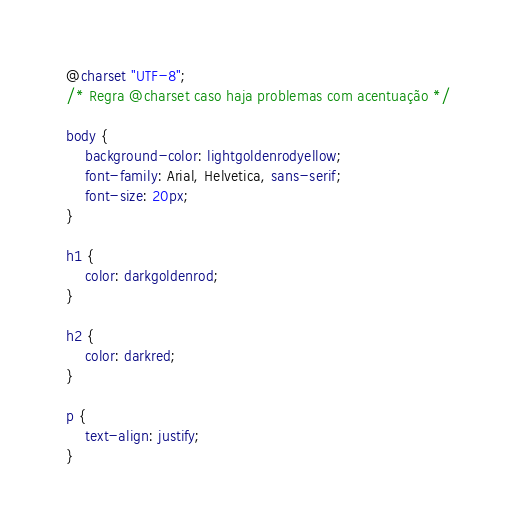<code> <loc_0><loc_0><loc_500><loc_500><_CSS_>@charset "UTF-8";
/* Regra @charset caso haja problemas com acentuação */

body {
    background-color: lightgoldenrodyellow;
    font-family: Arial, Helvetica, sans-serif;
    font-size: 20px;
}

h1 {
    color: darkgoldenrod;
}

h2 {
    color: darkred;
}

p {
    text-align: justify;
}</code> 